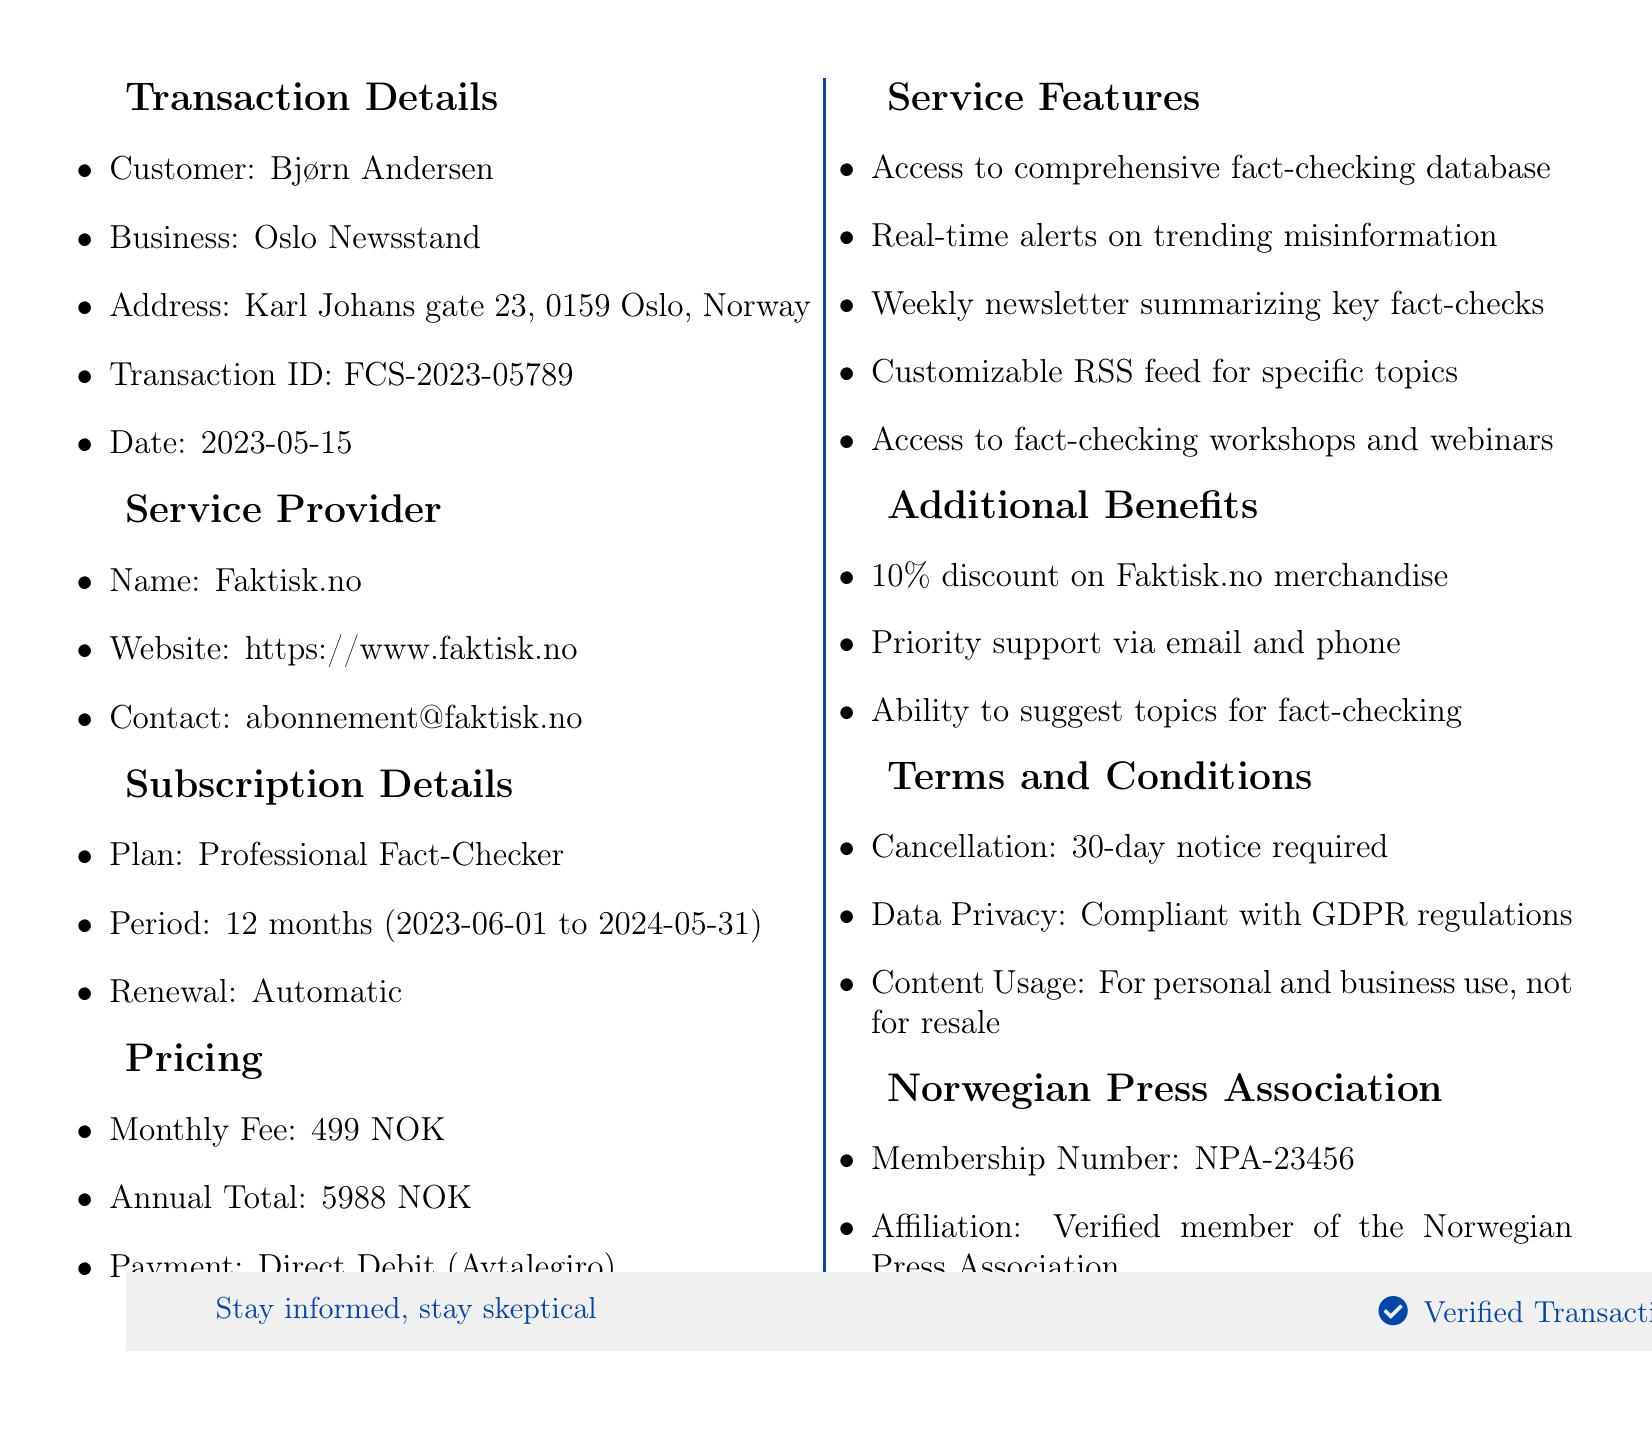What is the customer's name? The customer's name is listed in the transaction details section of the document.
Answer: Bjørn Andersen What is the business address? The business address can be found in the transaction details section of the document.
Answer: Karl Johans gate 23, 0159 Oslo, Norway What is the monthly fee for the subscription? The monthly fee is provided in the pricing section of the document.
Answer: 499 NOK When does the subscription period start? The start date of the subscription period is mentioned in the subscription details section of the document.
Answer: 2023-06-01 What is the cancellation policy? The cancellation policy is included in the terms and conditions section of the document.
Answer: 30-day notice required for cancellation How long is the subscription period? The subscription period is detailed in the subscription details section of the document.
Answer: 12 months What kind of alert service is included? The type of alerts is listed in the service features section of the document.
Answer: Real-time alerts on trending misinformation What membership number does the customer have with the Norwegian Press Association? The membership number is provided in the Norwegian Press Association section of the document.
Answer: NPA-23456 Is the subscription renewal type automatic? The renewal type is specified in the subscription details section of the document.
Answer: Automatic 